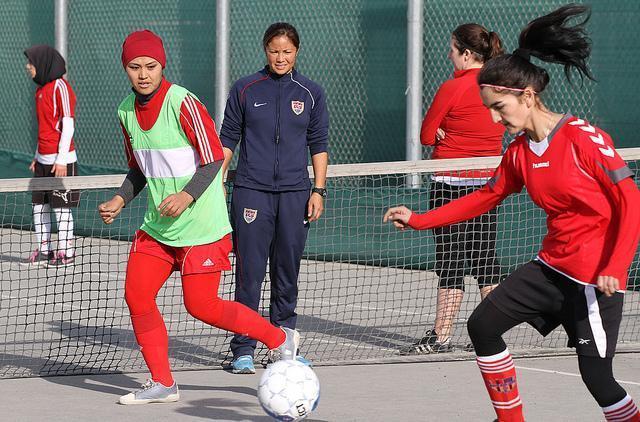How many balls are in the photo?
Give a very brief answer. 1. How many people are there?
Give a very brief answer. 5. 